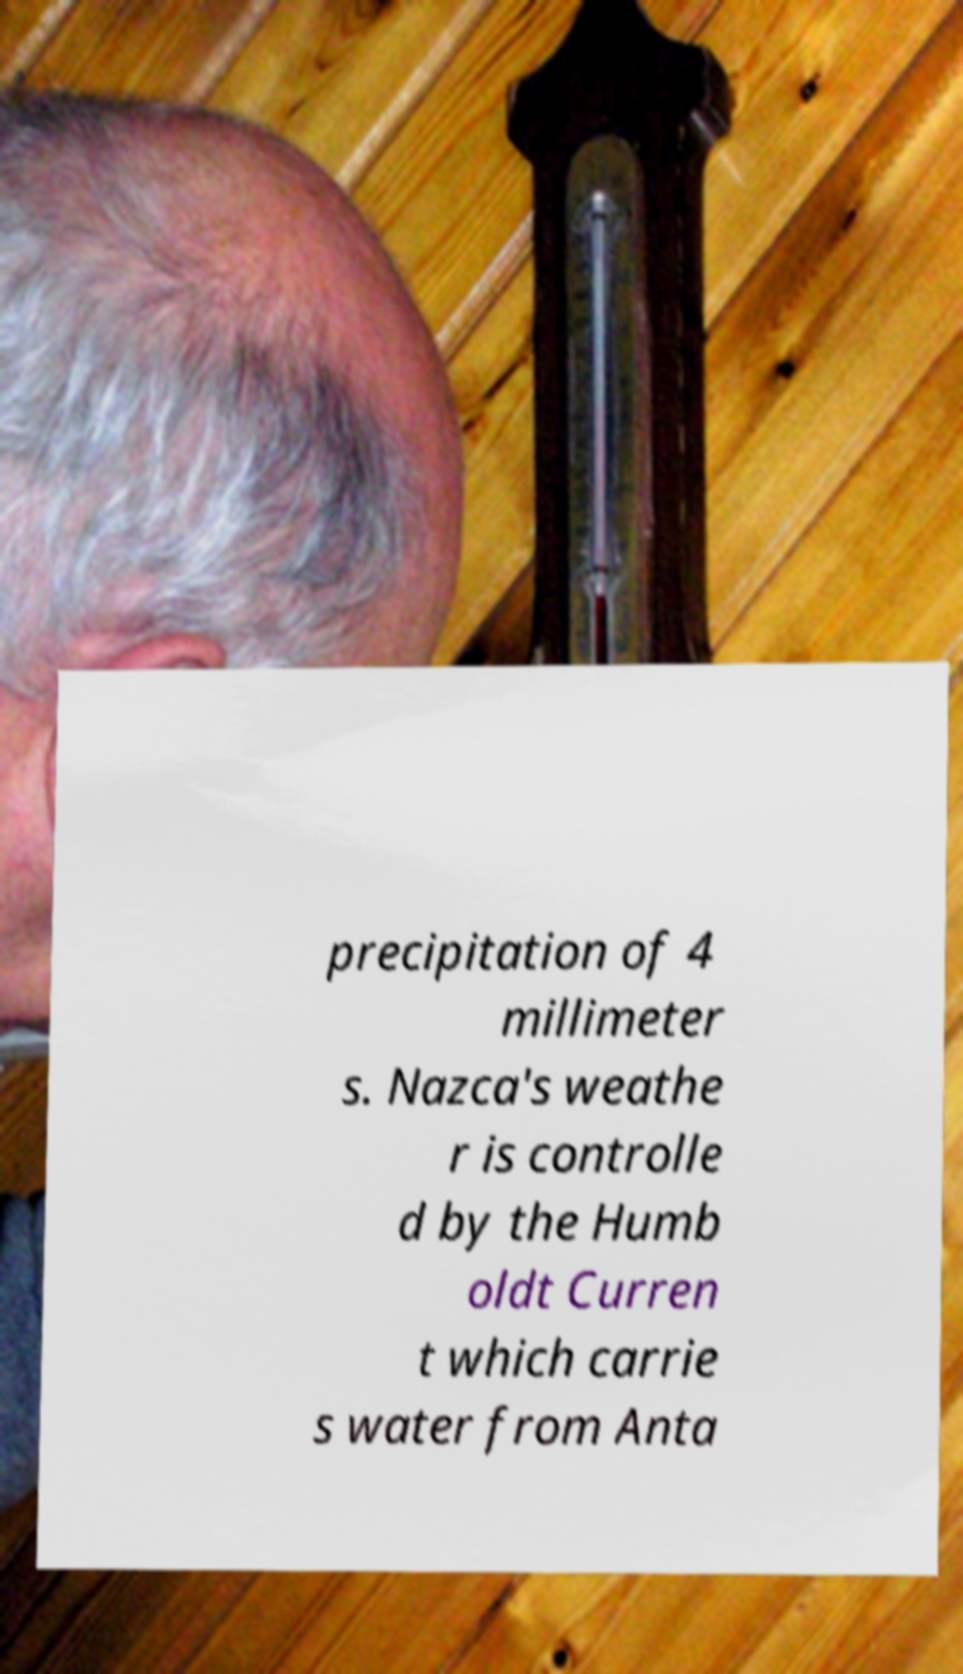Could you assist in decoding the text presented in this image and type it out clearly? precipitation of 4 millimeter s. Nazca's weathe r is controlle d by the Humb oldt Curren t which carrie s water from Anta 